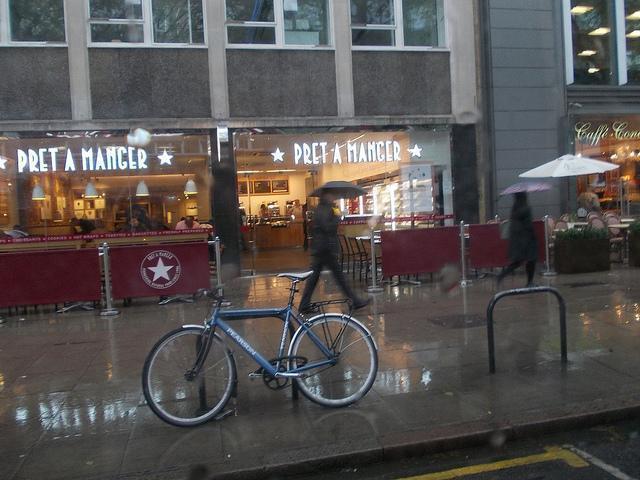What time of day is it here?
Pick the right solution, then justify: 'Answer: answer
Rationale: rationale.'
Options: Midday, midnight, noon, twilight. Answer: twilight.
Rationale: It's twilight since it's a little dark. 